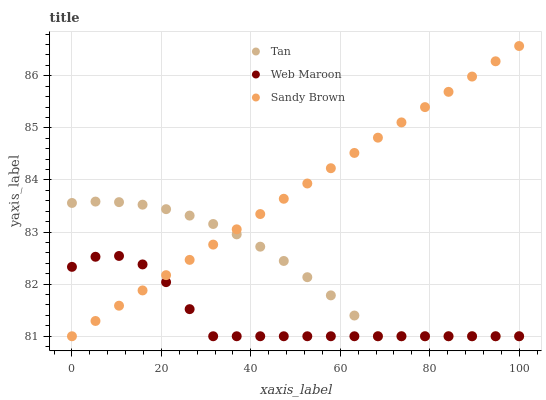Does Web Maroon have the minimum area under the curve?
Answer yes or no. Yes. Does Sandy Brown have the maximum area under the curve?
Answer yes or no. Yes. Does Tan have the minimum area under the curve?
Answer yes or no. No. Does Tan have the maximum area under the curve?
Answer yes or no. No. Is Sandy Brown the smoothest?
Answer yes or no. Yes. Is Web Maroon the roughest?
Answer yes or no. Yes. Is Tan the smoothest?
Answer yes or no. No. Is Tan the roughest?
Answer yes or no. No. Does Sandy Brown have the lowest value?
Answer yes or no. Yes. Does Sandy Brown have the highest value?
Answer yes or no. Yes. Does Tan have the highest value?
Answer yes or no. No. Does Tan intersect Web Maroon?
Answer yes or no. Yes. Is Tan less than Web Maroon?
Answer yes or no. No. Is Tan greater than Web Maroon?
Answer yes or no. No. 